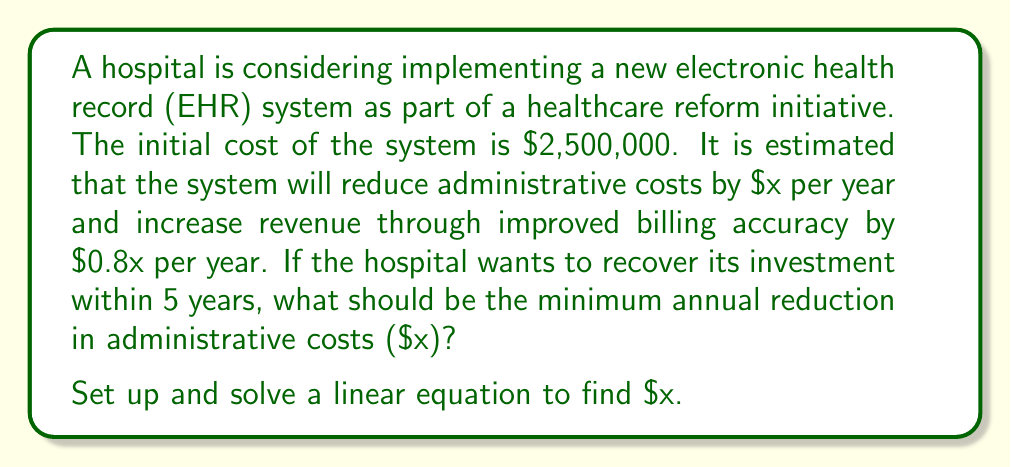Solve this math problem. Let's approach this step-by-step:

1) First, let's define our variables:
   $x$ = annual reduction in administrative costs
   $0.8x$ = annual increase in revenue due to improved billing accuracy

2) The total annual benefit is the sum of cost reduction and revenue increase:
   $x + 0.8x = 1.8x$

3) Over 5 years, the total benefit should at least equal the initial cost:
   $5(1.8x) \geq 2,500,000$

4) Let's solve this inequality:
   $9x \geq 2,500,000$

5) Divide both sides by 9:
   $x \geq \frac{2,500,000}{9}$

6) Calculate the result:
   $x \geq 277,777.78$

Therefore, the minimum annual reduction in administrative costs should be $277,778 (rounded up to the nearest dollar).
Answer: $277,778 